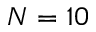<formula> <loc_0><loc_0><loc_500><loc_500>N = 1 0</formula> 